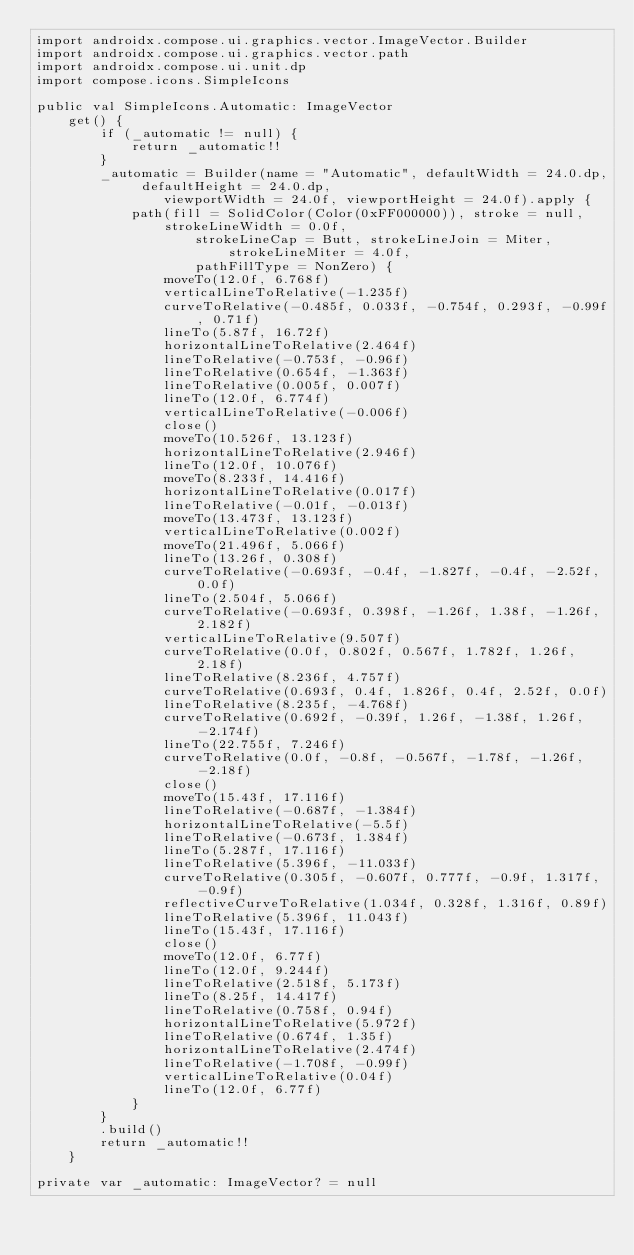<code> <loc_0><loc_0><loc_500><loc_500><_Kotlin_>import androidx.compose.ui.graphics.vector.ImageVector.Builder
import androidx.compose.ui.graphics.vector.path
import androidx.compose.ui.unit.dp
import compose.icons.SimpleIcons

public val SimpleIcons.Automatic: ImageVector
    get() {
        if (_automatic != null) {
            return _automatic!!
        }
        _automatic = Builder(name = "Automatic", defaultWidth = 24.0.dp, defaultHeight = 24.0.dp,
                viewportWidth = 24.0f, viewportHeight = 24.0f).apply {
            path(fill = SolidColor(Color(0xFF000000)), stroke = null, strokeLineWidth = 0.0f,
                    strokeLineCap = Butt, strokeLineJoin = Miter, strokeLineMiter = 4.0f,
                    pathFillType = NonZero) {
                moveTo(12.0f, 6.768f)
                verticalLineToRelative(-1.235f)
                curveToRelative(-0.485f, 0.033f, -0.754f, 0.293f, -0.99f, 0.71f)
                lineTo(5.87f, 16.72f)
                horizontalLineToRelative(2.464f)
                lineToRelative(-0.753f, -0.96f)
                lineToRelative(0.654f, -1.363f)
                lineToRelative(0.005f, 0.007f)
                lineTo(12.0f, 6.774f)
                verticalLineToRelative(-0.006f)
                close()
                moveTo(10.526f, 13.123f)
                horizontalLineToRelative(2.946f)
                lineTo(12.0f, 10.076f)
                moveTo(8.233f, 14.416f)
                horizontalLineToRelative(0.017f)
                lineToRelative(-0.01f, -0.013f)
                moveTo(13.473f, 13.123f)
                verticalLineToRelative(0.002f)
                moveTo(21.496f, 5.066f)
                lineTo(13.26f, 0.308f)
                curveToRelative(-0.693f, -0.4f, -1.827f, -0.4f, -2.52f, 0.0f)
                lineTo(2.504f, 5.066f)
                curveToRelative(-0.693f, 0.398f, -1.26f, 1.38f, -1.26f, 2.182f)
                verticalLineToRelative(9.507f)
                curveToRelative(0.0f, 0.802f, 0.567f, 1.782f, 1.26f, 2.18f)
                lineToRelative(8.236f, 4.757f)
                curveToRelative(0.693f, 0.4f, 1.826f, 0.4f, 2.52f, 0.0f)
                lineToRelative(8.235f, -4.768f)
                curveToRelative(0.692f, -0.39f, 1.26f, -1.38f, 1.26f, -2.174f)
                lineTo(22.755f, 7.246f)
                curveToRelative(0.0f, -0.8f, -0.567f, -1.78f, -1.26f, -2.18f)
                close()
                moveTo(15.43f, 17.116f)
                lineToRelative(-0.687f, -1.384f)
                horizontalLineToRelative(-5.5f)
                lineToRelative(-0.673f, 1.384f)
                lineTo(5.287f, 17.116f)
                lineToRelative(5.396f, -11.033f)
                curveToRelative(0.305f, -0.607f, 0.777f, -0.9f, 1.317f, -0.9f)
                reflectiveCurveToRelative(1.034f, 0.328f, 1.316f, 0.89f)
                lineToRelative(5.396f, 11.043f)
                lineTo(15.43f, 17.116f)
                close()
                moveTo(12.0f, 6.77f)
                lineTo(12.0f, 9.244f)
                lineToRelative(2.518f, 5.173f)
                lineTo(8.25f, 14.417f)
                lineToRelative(0.758f, 0.94f)
                horizontalLineToRelative(5.972f)
                lineToRelative(0.674f, 1.35f)
                horizontalLineToRelative(2.474f)
                lineToRelative(-1.708f, -0.99f)
                verticalLineToRelative(0.04f)
                lineTo(12.0f, 6.77f)
            }
        }
        .build()
        return _automatic!!
    }

private var _automatic: ImageVector? = null
</code> 